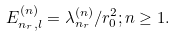Convert formula to latex. <formula><loc_0><loc_0><loc_500><loc_500>E _ { n _ { r } , l } ^ { ( n ) } = \lambda _ { n _ { r } } ^ { ( n ) } / r _ { 0 } ^ { 2 } ; n \geq 1 .</formula> 